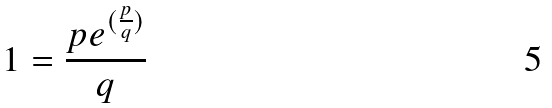Convert formula to latex. <formula><loc_0><loc_0><loc_500><loc_500>1 = \frac { p e ^ { ( \frac { p } { q } ) } } { q }</formula> 